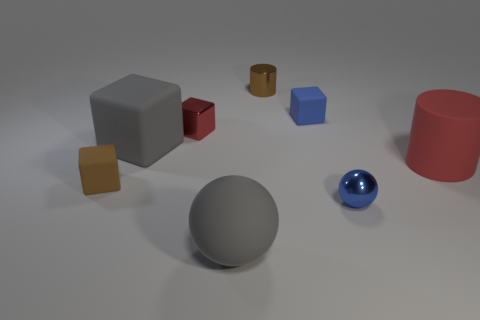Subtract all gray cubes. How many cubes are left? 3 Subtract all small metal blocks. How many blocks are left? 3 Subtract all green cubes. Subtract all green balls. How many cubes are left? 4 Add 1 small brown blocks. How many objects exist? 9 Subtract all cylinders. How many objects are left? 6 Subtract 1 blue blocks. How many objects are left? 7 Subtract all big red objects. Subtract all cubes. How many objects are left? 3 Add 4 red rubber cylinders. How many red rubber cylinders are left? 5 Add 4 big gray metallic cylinders. How many big gray metallic cylinders exist? 4 